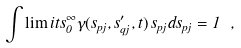Convert formula to latex. <formula><loc_0><loc_0><loc_500><loc_500>\int \lim i t s _ { 0 } ^ { \infty } \gamma ( s _ { p j } , s _ { q j } ^ { \prime } , t ) \, s _ { p j } d s _ { p j } = 1 \ ,</formula> 